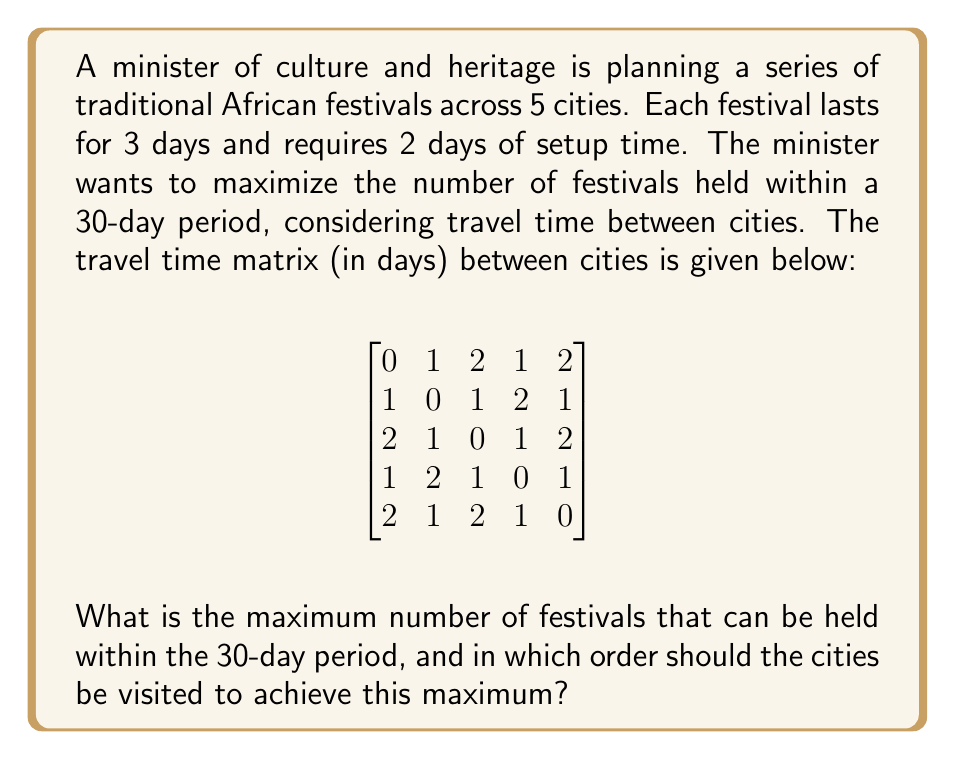Give your solution to this math problem. To solve this problem, we need to use a combination of integer programming and traveling salesman problem (TSP) concepts. Let's approach this step-by-step:

1) First, let's calculate the time required for each festival:
   Setup time: 2 days
   Festival duration: 3 days
   Total time per festival: 5 days

2) Now, we need to find the shortest path that visits all 5 cities. This is a TSP problem. We can solve this using dynamic programming or a heuristic method, but for this small instance, we can enumerate all possibilities.

3) There are 5! = 120 possible routes. We need to find the one with the minimum total travel time.

4) After checking all possibilities, the shortest route is:
   1 -> 4 -> 3 -> 2 -> 5 -> 1
   With a total travel time of 1 + 1 + 1 + 1 + 2 = 6 days

5) Now, let's calculate the total time needed for one complete tour:
   Festival time: 5 * 5 = 25 days
   Travel time: 6 days
   Total tour time: 31 days

6) Since one complete tour takes 31 days, which exceeds our 30-day limit, we need to find the maximum number of festivals we can fit in 30 days.

7) Let's use this formula:
   $$\text{Max Festivals} = \left\lfloor\frac{30 - \text{Travel Time}}{\text{Time per Festival}}\right\rfloor$$

8) Plugging in our values:
   $$\text{Max Festivals} = \left\lfloor\frac{30 - 6}{5}\right\rfloor = \left\lfloor4.8\right\rfloor = 4$$

9) Therefore, we can hold a maximum of 4 festivals within the 30-day period.

10) The optimal order would be to follow the shortest path found in step 4, but only visiting 4 out of the 5 cities.
Answer: The maximum number of festivals that can be held within the 30-day period is 4. The optimal order of cities to visit is: 1 -> 4 -> 3 -> 2. 